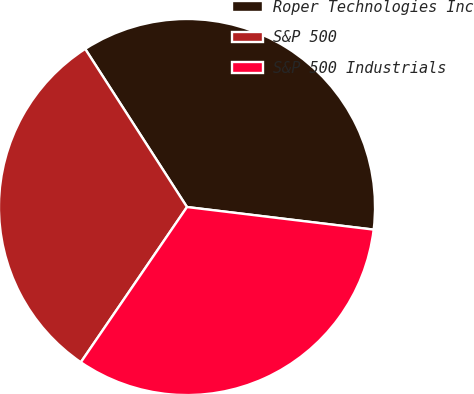Convert chart to OTSL. <chart><loc_0><loc_0><loc_500><loc_500><pie_chart><fcel>Roper Technologies Inc<fcel>S&P 500<fcel>S&P 500 Industrials<nl><fcel>36.02%<fcel>31.35%<fcel>32.63%<nl></chart> 